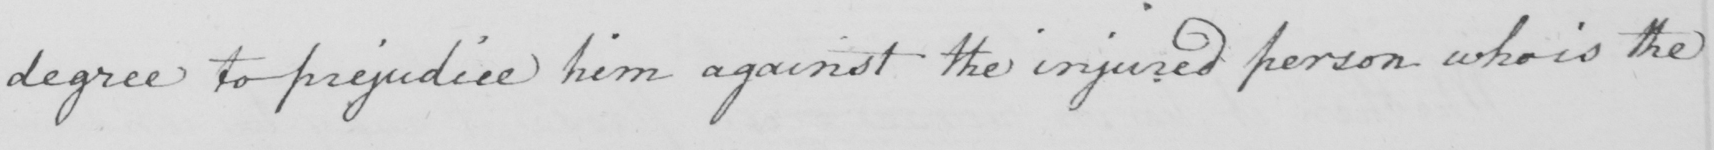What text is written in this handwritten line? degree to prejudice him against the injured person who is the 